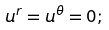<formula> <loc_0><loc_0><loc_500><loc_500>u ^ { r } = u ^ { \theta } = 0 ;</formula> 